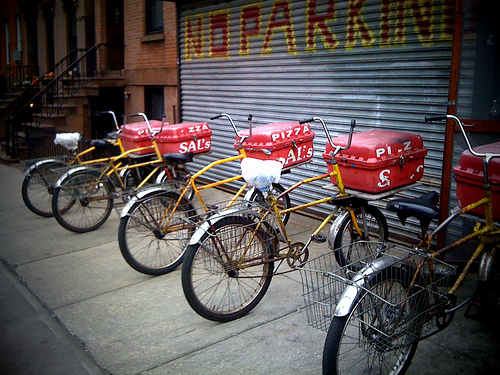<image>What is the red thing on the back of the bike? I don't know what the red thing on the back of the bike is. It can be a basket, a pizza box or a crate. What is the red thing on the back of the bike? I am not sure what the red thing on the back of the bike is. It can be a crate, a pizza box, a trunk, a basket, or a hotbox. 